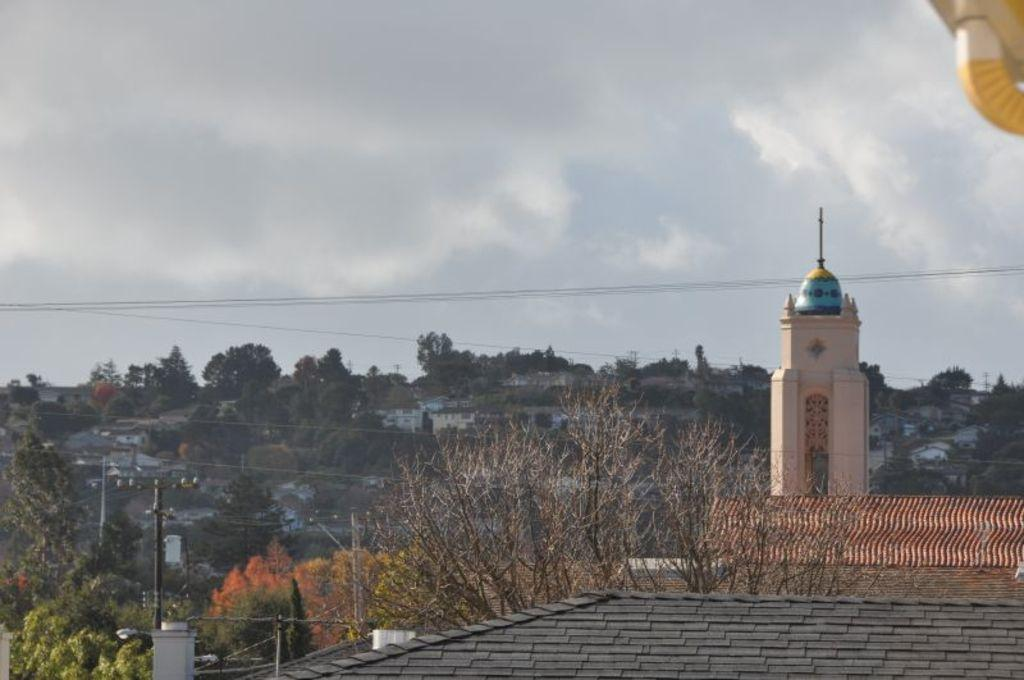What type of natural elements can be seen in the image? There are trees in the image. What type of man-made structures are present in the image? There are buildings in the image. What type of infrastructure is present in the image? Electric poles with cables are present in the image. What is visible in the sky at the top of the image? Clouds are visible in the sky at the top of the image. What type of fruit is hanging from the trees in the image? There is no fruit visible on the trees in the image. How does the beginner learn to use the buildings in the image? The image does not depict any learning or teaching activities, nor does it show any people interacting with the buildings. --- Facts: 1. There is a person sitting on a chair in the image. 2. The person is holding a book. 3. The book has a red cover. 4. There is a table next to the chair. 5. There is a lamp on the table. Absurd Topics: elephant, ocean, dance Conversation: What is the person in the image doing? The person is sitting on a chair in the image. What is the person holding in the image? The person is holding a book in the image. What color is the book's cover? The book has a red cover. What is located next to the chair in the image? There is a table next to the chair in the image. What is on the table in the image? There is a lamp on the table in the image. Reasoning: Let's think step by step in order to produce the conversation. We start by identifying the main subject in the image, which is the person sitting on a chair. Then, we expand the conversation to include other items that are also visible, such as the book, the table, and the lamp. Each question is designed to elicit a specific detail about the image that is known from the provided facts. Absurd Question/Answer: Can you see an elephant swimming in the ocean in the image? No, there is no elephant or ocean present in the image. Is the person in the image dancing while holding the book? No, the person is sitting and holding the book, not dancing. 